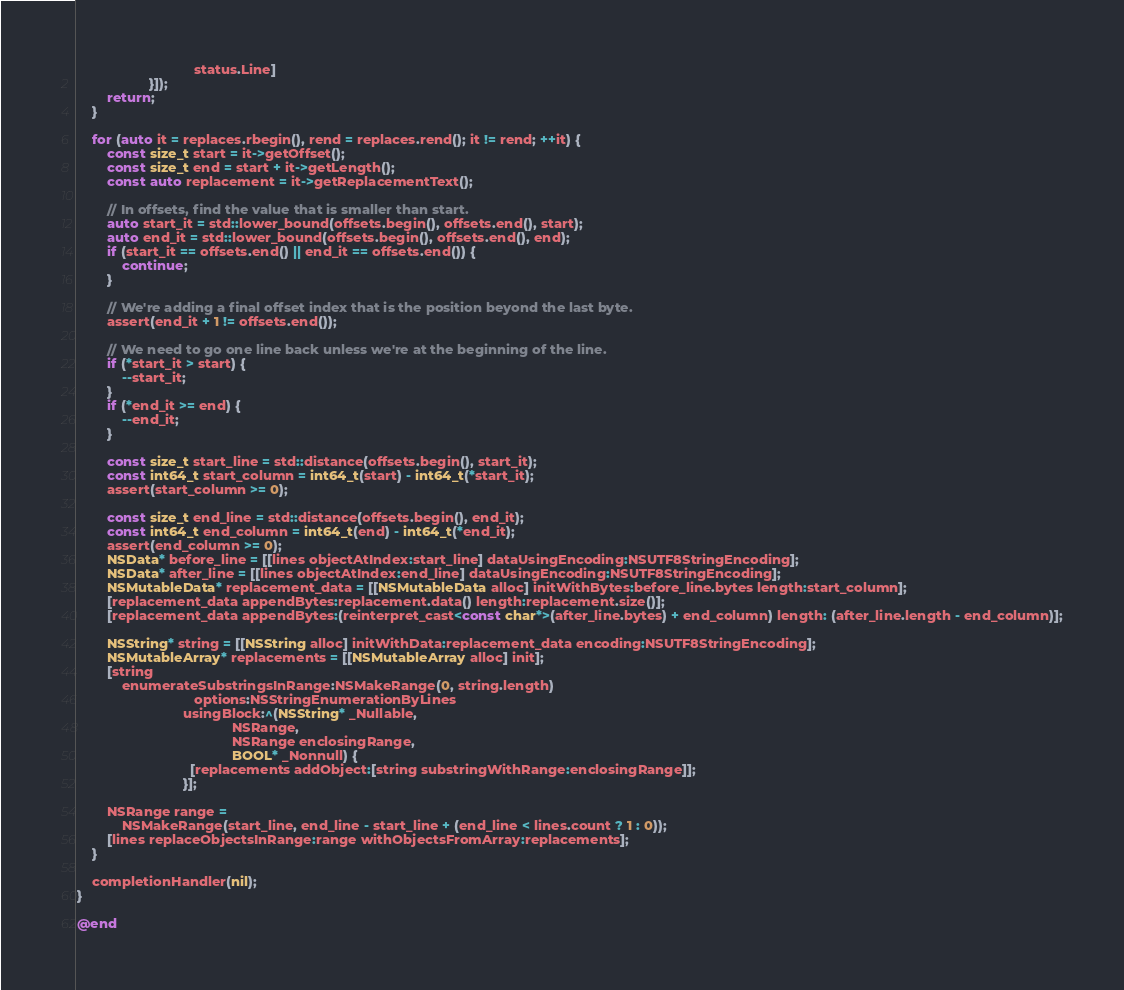Convert code to text. <code><loc_0><loc_0><loc_500><loc_500><_ObjectiveC_>                               status.Line]
                   }]);
        return;
    }

    for (auto it = replaces.rbegin(), rend = replaces.rend(); it != rend; ++it) {
        const size_t start = it->getOffset();
        const size_t end = start + it->getLength();
        const auto replacement = it->getReplacementText();

        // In offsets, find the value that is smaller than start.
        auto start_it = std::lower_bound(offsets.begin(), offsets.end(), start);
        auto end_it = std::lower_bound(offsets.begin(), offsets.end(), end);
        if (start_it == offsets.end() || end_it == offsets.end()) {
            continue;
        }

        // We're adding a final offset index that is the position beyond the last byte.
        assert(end_it + 1 != offsets.end());

        // We need to go one line back unless we're at the beginning of the line.
        if (*start_it > start) {
            --start_it;
        }
        if (*end_it >= end) {
            --end_it;
        }

        const size_t start_line = std::distance(offsets.begin(), start_it);
        const int64_t start_column = int64_t(start) - int64_t(*start_it);
        assert(start_column >= 0);

        const size_t end_line = std::distance(offsets.begin(), end_it);
        const int64_t end_column = int64_t(end) - int64_t(*end_it);
        assert(end_column >= 0);
        NSData* before_line = [[lines objectAtIndex:start_line] dataUsingEncoding:NSUTF8StringEncoding];
        NSData* after_line = [[lines objectAtIndex:end_line] dataUsingEncoding:NSUTF8StringEncoding];
        NSMutableData* replacement_data = [[NSMutableData alloc] initWithBytes:before_line.bytes length:start_column];
        [replacement_data appendBytes:replacement.data() length:replacement.size()];
        [replacement_data appendBytes:(reinterpret_cast<const char*>(after_line.bytes) + end_column) length: (after_line.length - end_column)];

        NSString* string = [[NSString alloc] initWithData:replacement_data encoding:NSUTF8StringEncoding];
        NSMutableArray* replacements = [[NSMutableArray alloc] init];
        [string
            enumerateSubstringsInRange:NSMakeRange(0, string.length)
                               options:NSStringEnumerationByLines
                            usingBlock:^(NSString* _Nullable,
                                         NSRange,
                                         NSRange enclosingRange,
                                         BOOL* _Nonnull) {
                              [replacements addObject:[string substringWithRange:enclosingRange]];
                            }];

        NSRange range =
            NSMakeRange(start_line, end_line - start_line + (end_line < lines.count ? 1 : 0));
        [lines replaceObjectsInRange:range withObjectsFromArray:replacements];
    }

    completionHandler(nil);
}

@end
</code> 